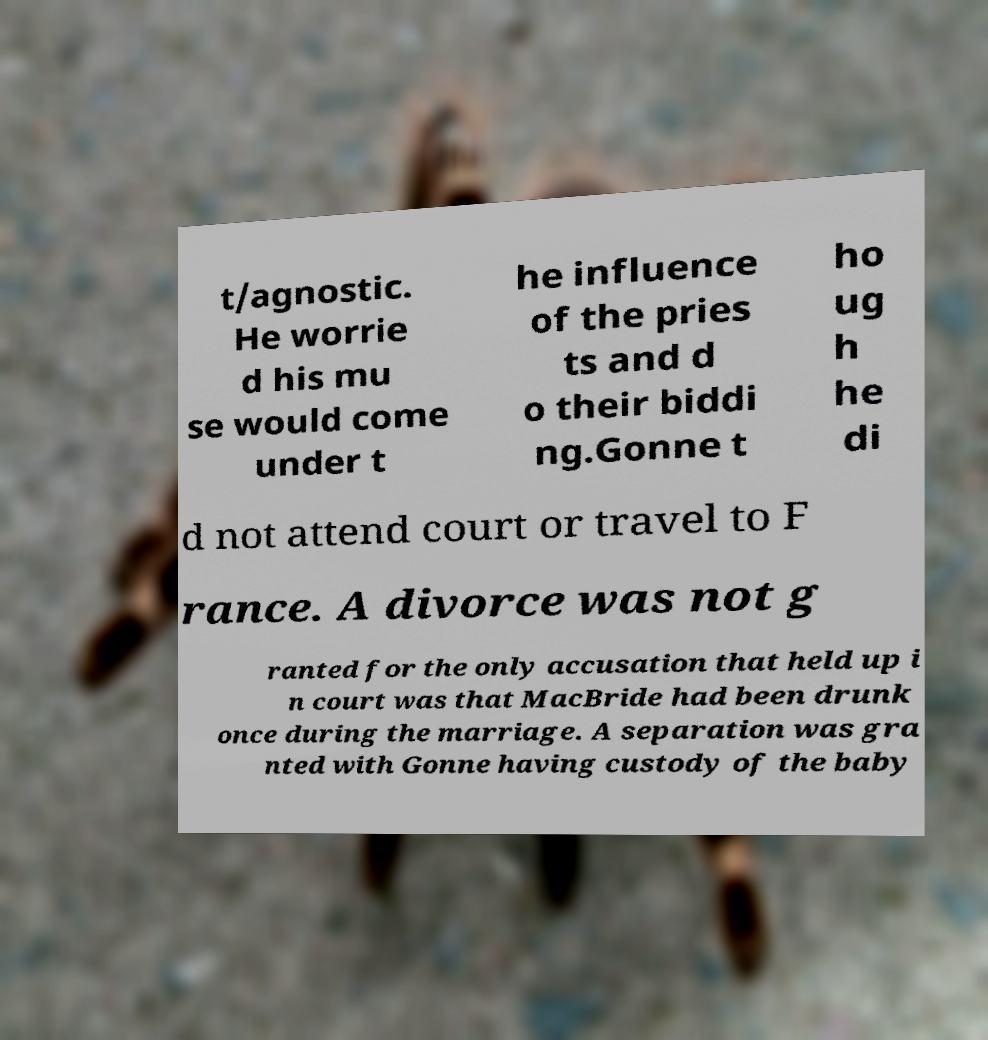Can you accurately transcribe the text from the provided image for me? t/agnostic. He worrie d his mu se would come under t he influence of the pries ts and d o their biddi ng.Gonne t ho ug h he di d not attend court or travel to F rance. A divorce was not g ranted for the only accusation that held up i n court was that MacBride had been drunk once during the marriage. A separation was gra nted with Gonne having custody of the baby 